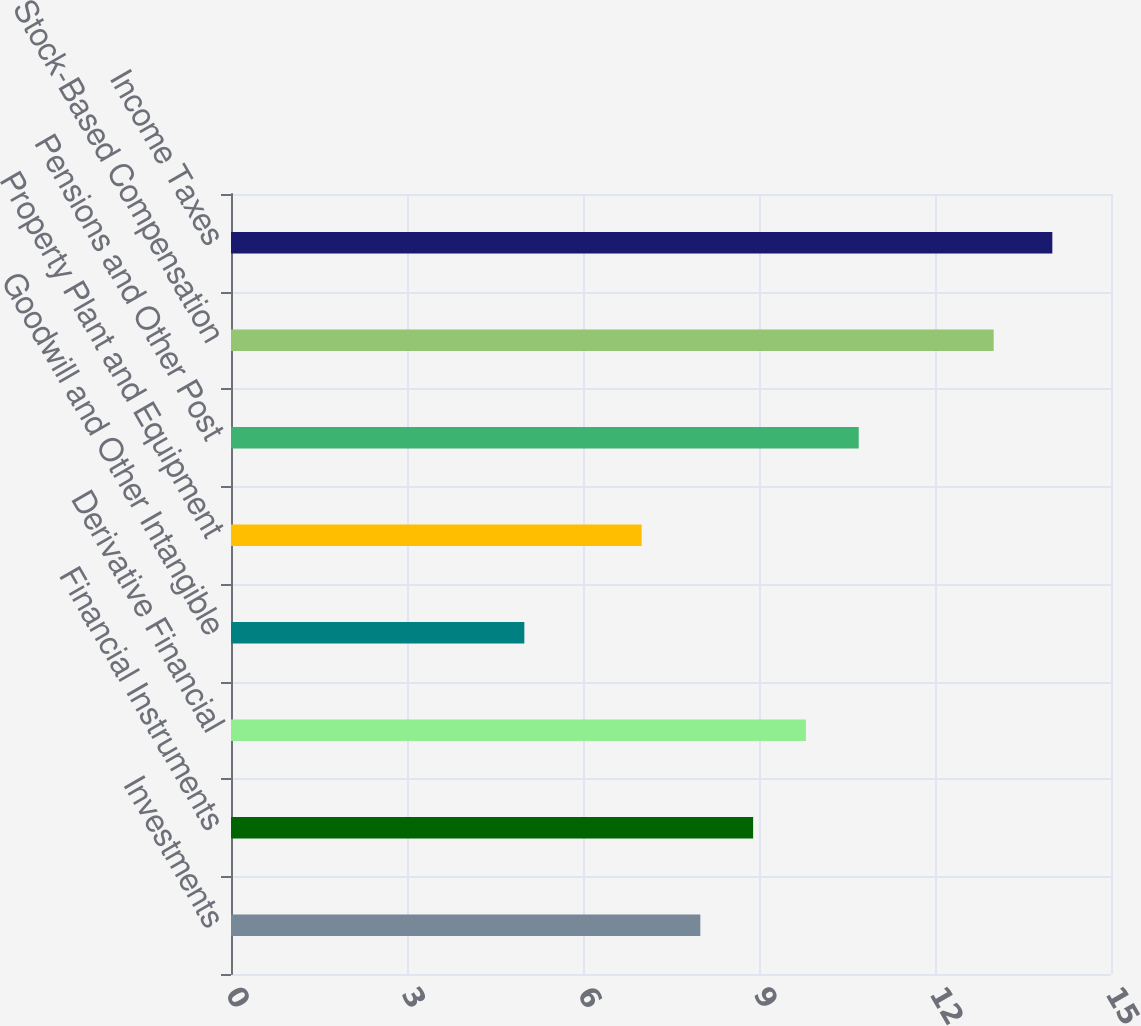Convert chart. <chart><loc_0><loc_0><loc_500><loc_500><bar_chart><fcel>Investments<fcel>Financial Instruments<fcel>Derivative Financial<fcel>Goodwill and Other Intangible<fcel>Property Plant and Equipment<fcel>Pensions and Other Post<fcel>Stock-Based Compensation<fcel>Income Taxes<nl><fcel>8<fcel>8.9<fcel>9.8<fcel>5<fcel>7<fcel>10.7<fcel>13<fcel>14<nl></chart> 